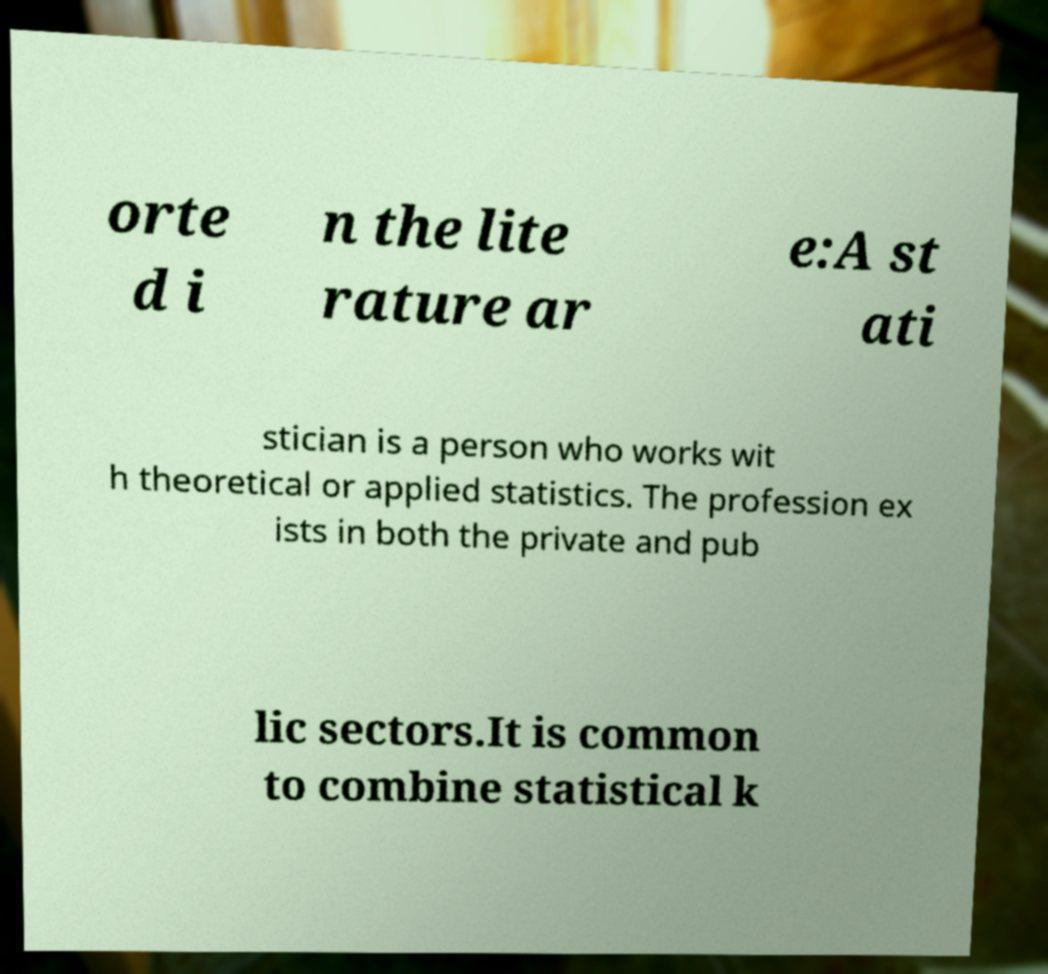For documentation purposes, I need the text within this image transcribed. Could you provide that? orte d i n the lite rature ar e:A st ati stician is a person who works wit h theoretical or applied statistics. The profession ex ists in both the private and pub lic sectors.It is common to combine statistical k 